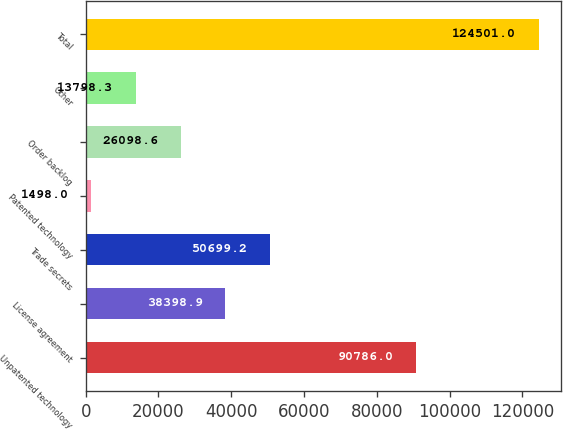Convert chart. <chart><loc_0><loc_0><loc_500><loc_500><bar_chart><fcel>Unpatented technology<fcel>License agreement<fcel>Trade secrets<fcel>Patented technology<fcel>Order backlog<fcel>Other<fcel>Total<nl><fcel>90786<fcel>38398.9<fcel>50699.2<fcel>1498<fcel>26098.6<fcel>13798.3<fcel>124501<nl></chart> 